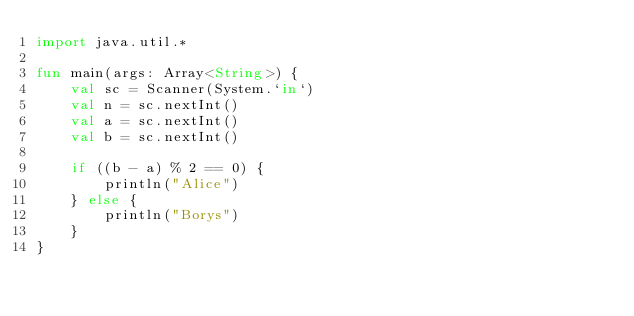Convert code to text. <code><loc_0><loc_0><loc_500><loc_500><_Kotlin_>import java.util.*

fun main(args: Array<String>) {
    val sc = Scanner(System.`in`)
    val n = sc.nextInt()
    val a = sc.nextInt()
    val b = sc.nextInt()

    if ((b - a) % 2 == 0) {
        println("Alice")
    } else {
        println("Borys")
    }
}
</code> 